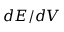<formula> <loc_0><loc_0><loc_500><loc_500>d E / d V</formula> 